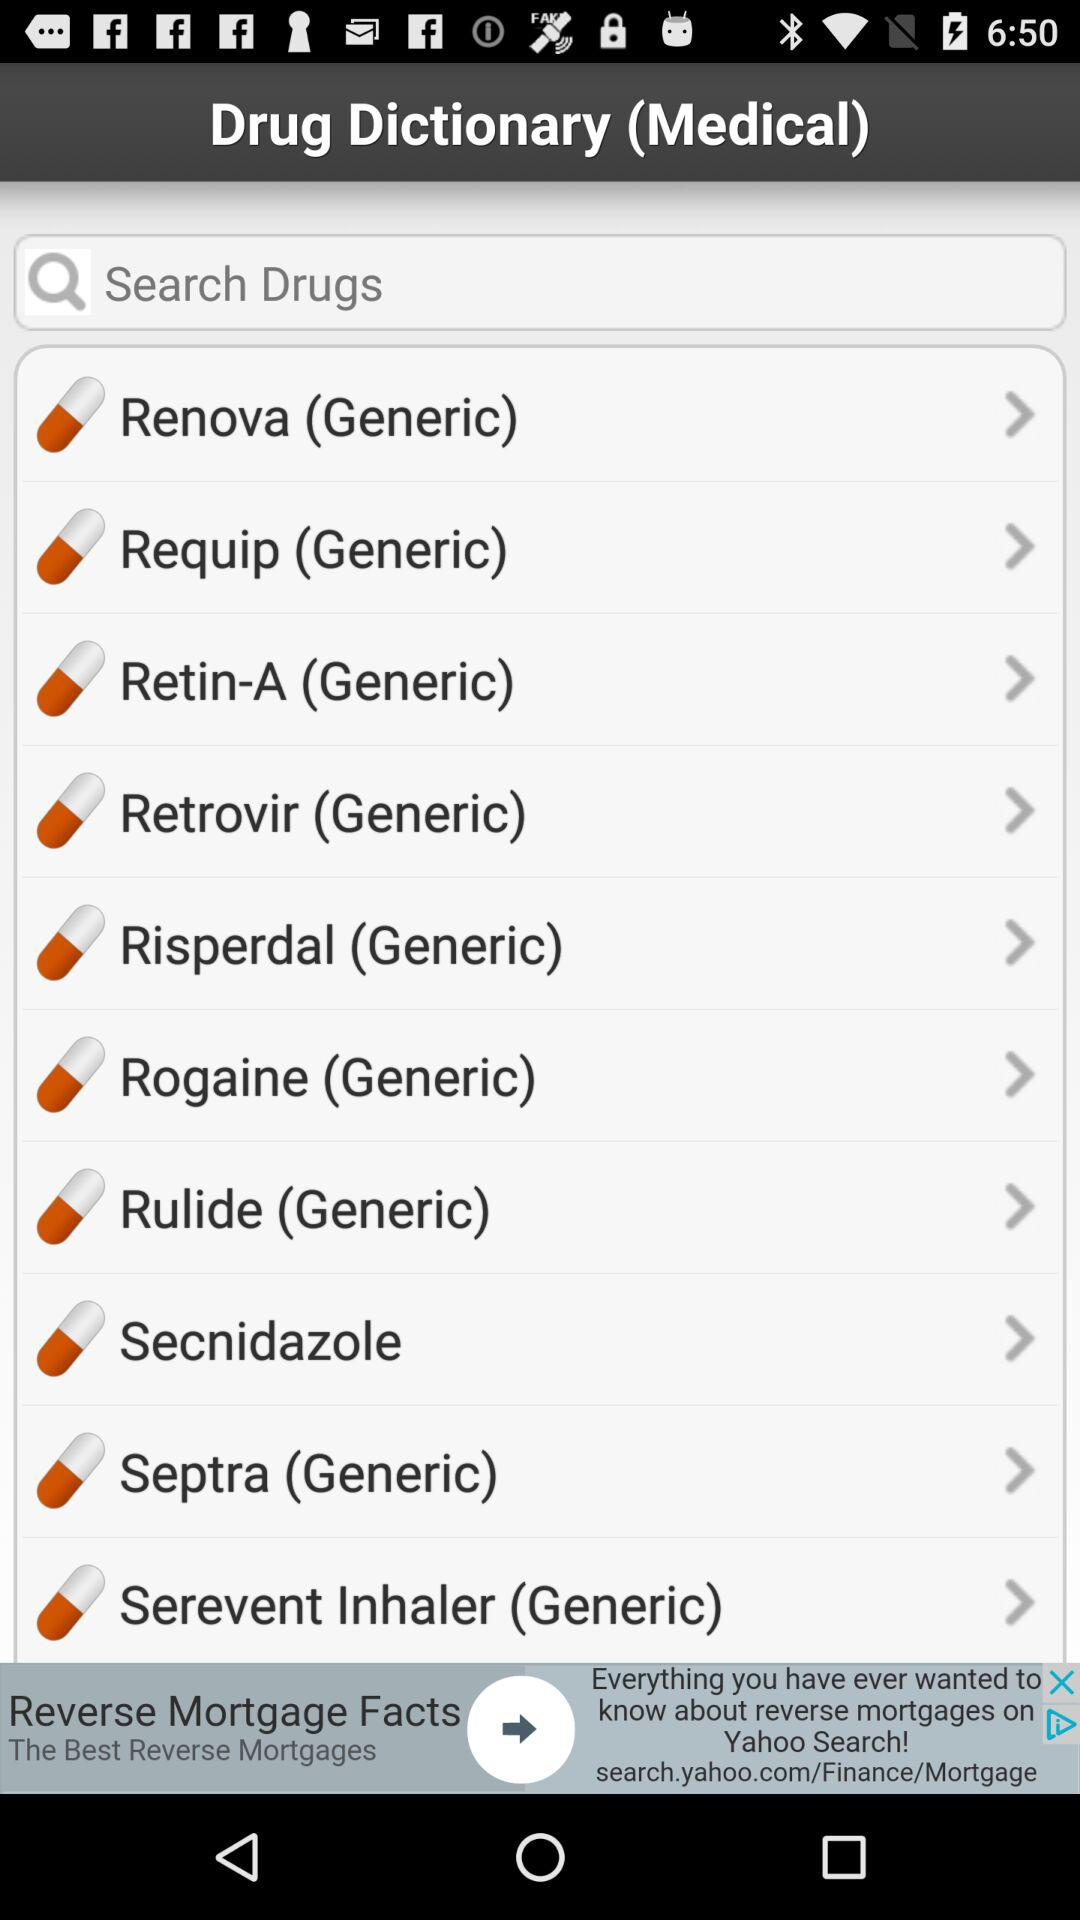What is the name of the application?
When the provided information is insufficient, respond with <no answer>. <no answer> 